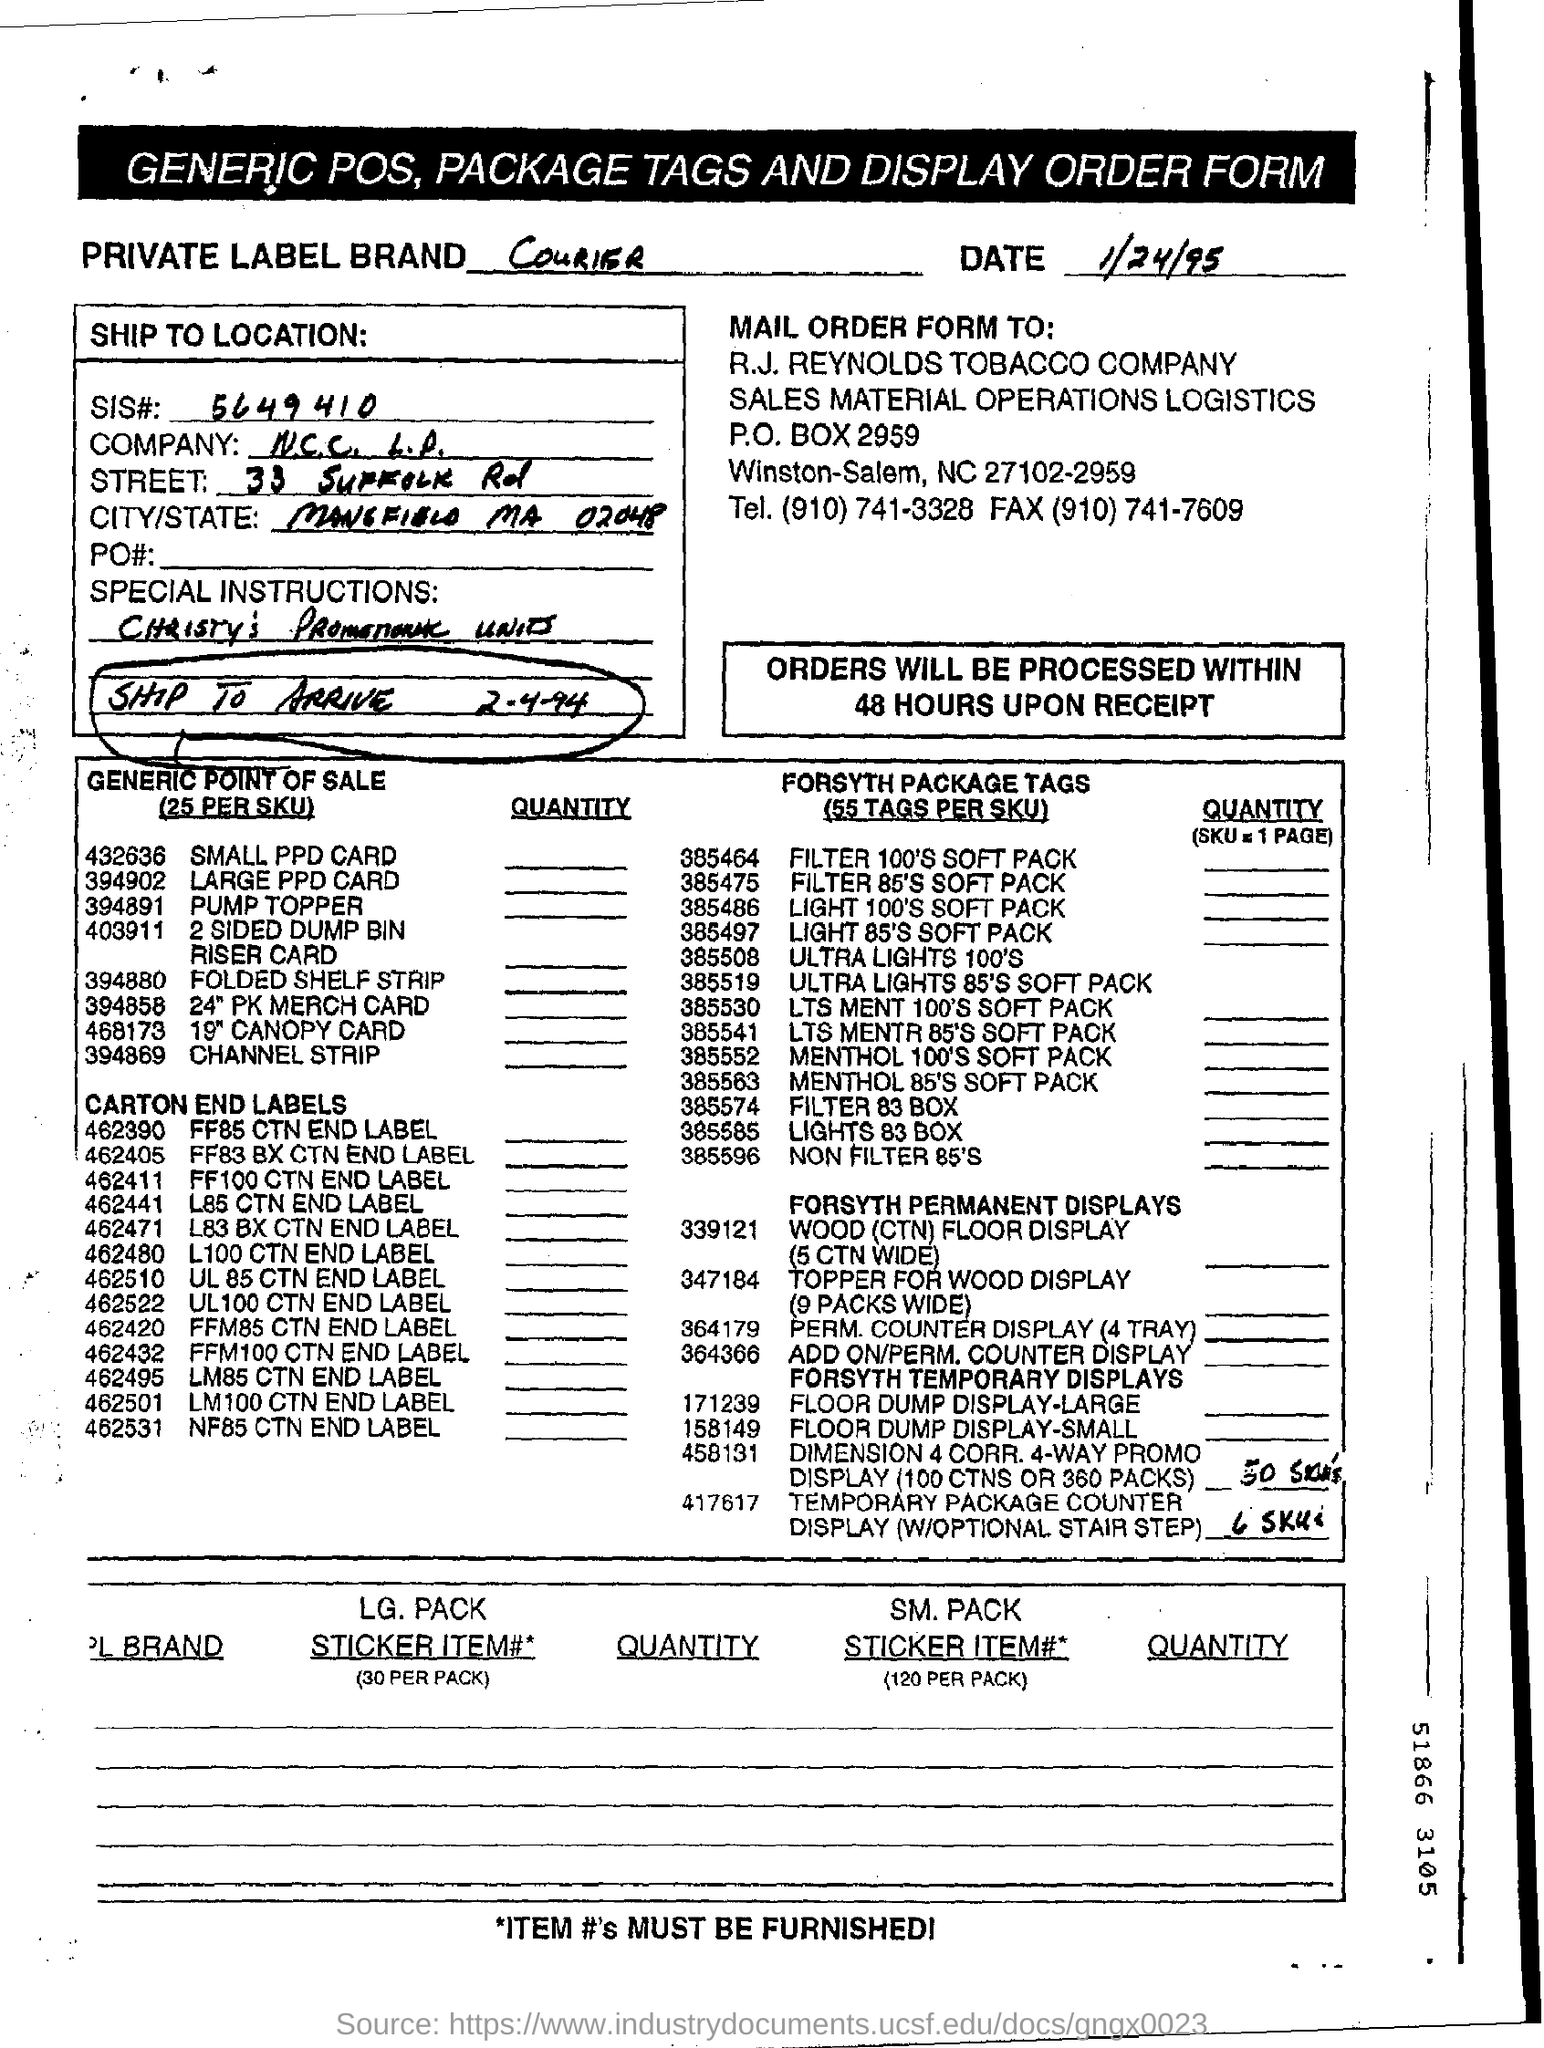Outline some significant characteristics in this image. The form is dated on 1/24/95. This is a generic POS system with package tags and a display order form. Orders will be processed within 48 hours of receipt. What is the SIS number? It is 5649410... 